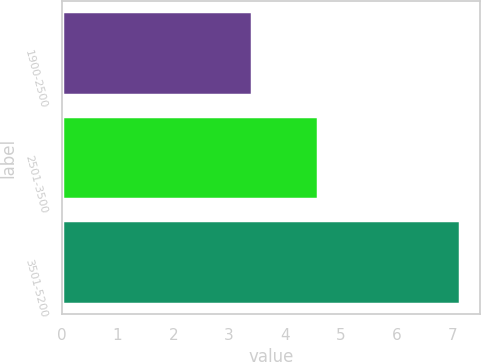Convert chart to OTSL. <chart><loc_0><loc_0><loc_500><loc_500><bar_chart><fcel>1900-2500<fcel>2501-3500<fcel>3501-5200<nl><fcel>3.42<fcel>4.59<fcel>7.14<nl></chart> 